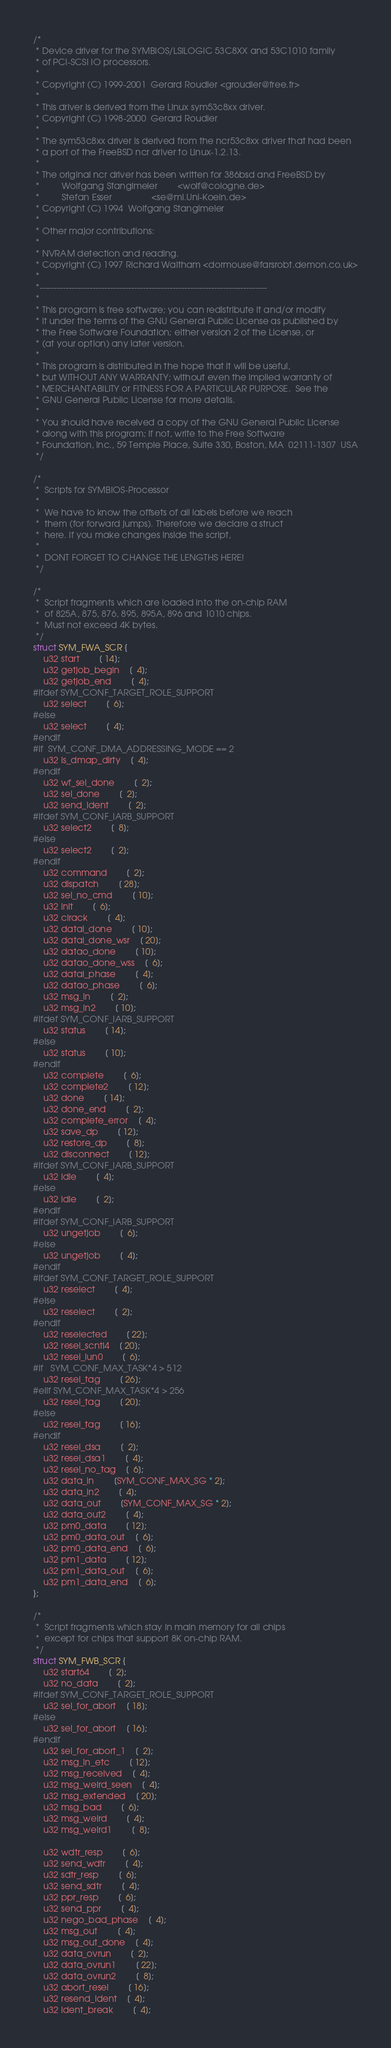Convert code to text. <code><loc_0><loc_0><loc_500><loc_500><_C_>/*
 * Device driver for the SYMBIOS/LSILOGIC 53C8XX and 53C1010 family
 * of PCI-SCSI IO processors.
 *
 * Copyright (C) 1999-2001  Gerard Roudier <groudier@free.fr>
 *
 * This driver is derived from the Linux sym53c8xx driver.
 * Copyright (C) 1998-2000  Gerard Roudier
 *
 * The sym53c8xx driver is derived from the ncr53c8xx driver that had been
 * a port of the FreeBSD ncr driver to Linux-1.2.13.
 *
 * The original ncr driver has been written for 386bsd and FreeBSD by
 *         Wolfgang Stanglmeier        <wolf@cologne.de>
 *         Stefan Esser                <se@mi.Uni-Koeln.de>
 * Copyright (C) 1994  Wolfgang Stanglmeier
 *
 * Other major contributions:
 *
 * NVRAM detection and reading.
 * Copyright (C) 1997 Richard Waltham <dormouse@farsrobt.demon.co.uk>
 *
 *-----------------------------------------------------------------------------
 *
 * This program is free software; you can redistribute it and/or modify
 * it under the terms of the GNU General Public License as published by
 * the Free Software Foundation; either version 2 of the License, or
 * (at your option) any later version.
 *
 * This program is distributed in the hope that it will be useful,
 * but WITHOUT ANY WARRANTY; without even the implied warranty of
 * MERCHANTABILITY or FITNESS FOR A PARTICULAR PURPOSE.  See the
 * GNU General Public License for more details.
 *
 * You should have received a copy of the GNU General Public License
 * along with this program; if not, write to the Free Software
 * Foundation, Inc., 59 Temple Place, Suite 330, Boston, MA  02111-1307  USA
 */

/*
 *  Scripts for SYMBIOS-Processor
 *
 *  We have to know the offsets of all labels before we reach
 *  them (for forward jumps). Therefore we declare a struct
 *  here. If you make changes inside the script,
 *
 *  DONT FORGET TO CHANGE THE LENGTHS HERE!
 */

/*
 *  Script fragments which are loaded into the on-chip RAM
 *  of 825A, 875, 876, 895, 895A, 896 and 1010 chips.
 *  Must not exceed 4K bytes.
 */
struct SYM_FWA_SCR {
	u32 start		[ 14];
	u32 getjob_begin	[  4];
	u32 getjob_end		[  4];
#ifdef SYM_CONF_TARGET_ROLE_SUPPORT
	u32 select		[  6];
#else
	u32 select		[  4];
#endif
#if	SYM_CONF_DMA_ADDRESSING_MODE == 2
	u32 is_dmap_dirty	[  4];
#endif
	u32 wf_sel_done		[  2];
	u32 sel_done		[  2];
	u32 send_ident		[  2];
#ifdef SYM_CONF_IARB_SUPPORT
	u32 select2		[  8];
#else
	u32 select2		[  2];
#endif
	u32 command		[  2];
	u32 dispatch		[ 28];
	u32 sel_no_cmd		[ 10];
	u32 init		[  6];
	u32 clrack		[  4];
	u32 datai_done		[ 10];
	u32 datai_done_wsr	[ 20];
	u32 datao_done		[ 10];
	u32 datao_done_wss	[  6];
	u32 datai_phase		[  4];
	u32 datao_phase		[  6];
	u32 msg_in		[  2];
	u32 msg_in2		[ 10];
#ifdef SYM_CONF_IARB_SUPPORT
	u32 status		[ 14];
#else
	u32 status		[ 10];
#endif
	u32 complete		[  6];
	u32 complete2		[ 12];
	u32 done		[ 14];
	u32 done_end		[  2];
	u32 complete_error	[  4];
	u32 save_dp		[ 12];
	u32 restore_dp		[  8];
	u32 disconnect		[ 12];
#ifdef SYM_CONF_IARB_SUPPORT
	u32 idle		[  4];
#else
	u32 idle		[  2];
#endif
#ifdef SYM_CONF_IARB_SUPPORT
	u32 ungetjob		[  6];
#else
	u32 ungetjob		[  4];
#endif
#ifdef SYM_CONF_TARGET_ROLE_SUPPORT
	u32 reselect		[  4];
#else
	u32 reselect		[  2];
#endif
	u32 reselected		[ 22];
	u32 resel_scntl4	[ 20];
	u32 resel_lun0		[  6];
#if   SYM_CONF_MAX_TASK*4 > 512
	u32 resel_tag		[ 26];
#elif SYM_CONF_MAX_TASK*4 > 256
	u32 resel_tag		[ 20];
#else
	u32 resel_tag		[ 16];
#endif
	u32 resel_dsa		[  2];
	u32 resel_dsa1		[  4];
	u32 resel_no_tag	[  6];
	u32 data_in		[SYM_CONF_MAX_SG * 2];
	u32 data_in2		[  4];
	u32 data_out		[SYM_CONF_MAX_SG * 2];
	u32 data_out2		[  4];
	u32 pm0_data		[ 12];
	u32 pm0_data_out	[  6];
	u32 pm0_data_end	[  6];
	u32 pm1_data		[ 12];
	u32 pm1_data_out	[  6];
	u32 pm1_data_end	[  6];
};

/*
 *  Script fragments which stay in main memory for all chips
 *  except for chips that support 8K on-chip RAM.
 */
struct SYM_FWB_SCR {
	u32 start64		[  2];
	u32 no_data		[  2];
#ifdef SYM_CONF_TARGET_ROLE_SUPPORT
	u32 sel_for_abort	[ 18];
#else
	u32 sel_for_abort	[ 16];
#endif
	u32 sel_for_abort_1	[  2];
	u32 msg_in_etc		[ 12];
	u32 msg_received	[  4];
	u32 msg_weird_seen	[  4];
	u32 msg_extended	[ 20];
	u32 msg_bad		[  6];
	u32 msg_weird		[  4];
	u32 msg_weird1		[  8];

	u32 wdtr_resp		[  6];
	u32 send_wdtr		[  4];
	u32 sdtr_resp		[  6];
	u32 send_sdtr		[  4];
	u32 ppr_resp		[  6];
	u32 send_ppr		[  4];
	u32 nego_bad_phase	[  4];
	u32 msg_out		[  4];
	u32 msg_out_done	[  4];
	u32 data_ovrun		[  2];
	u32 data_ovrun1		[ 22];
	u32 data_ovrun2		[  8];
	u32 abort_resel		[ 16];
	u32 resend_ident	[  4];
	u32 ident_break		[  4];</code> 